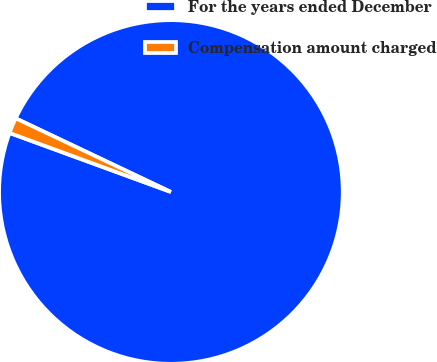Convert chart. <chart><loc_0><loc_0><loc_500><loc_500><pie_chart><fcel>For the years ended December<fcel>Compensation amount charged<nl><fcel>98.53%<fcel>1.47%<nl></chart> 